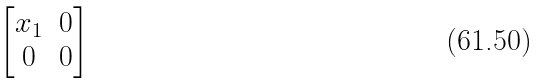Convert formula to latex. <formula><loc_0><loc_0><loc_500><loc_500>\begin{bmatrix} x _ { 1 } & 0 \\ 0 & 0 \end{bmatrix}</formula> 